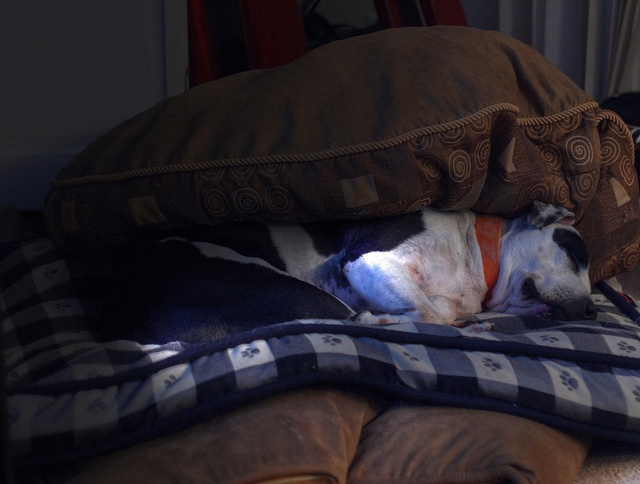Describe the objects in this image and their specific colors. I can see bed in black, maroon, and gray tones and dog in black, gray, and navy tones in this image. 